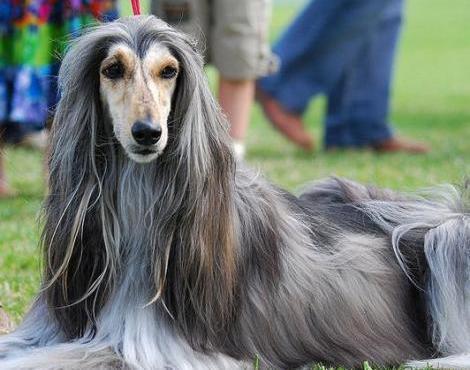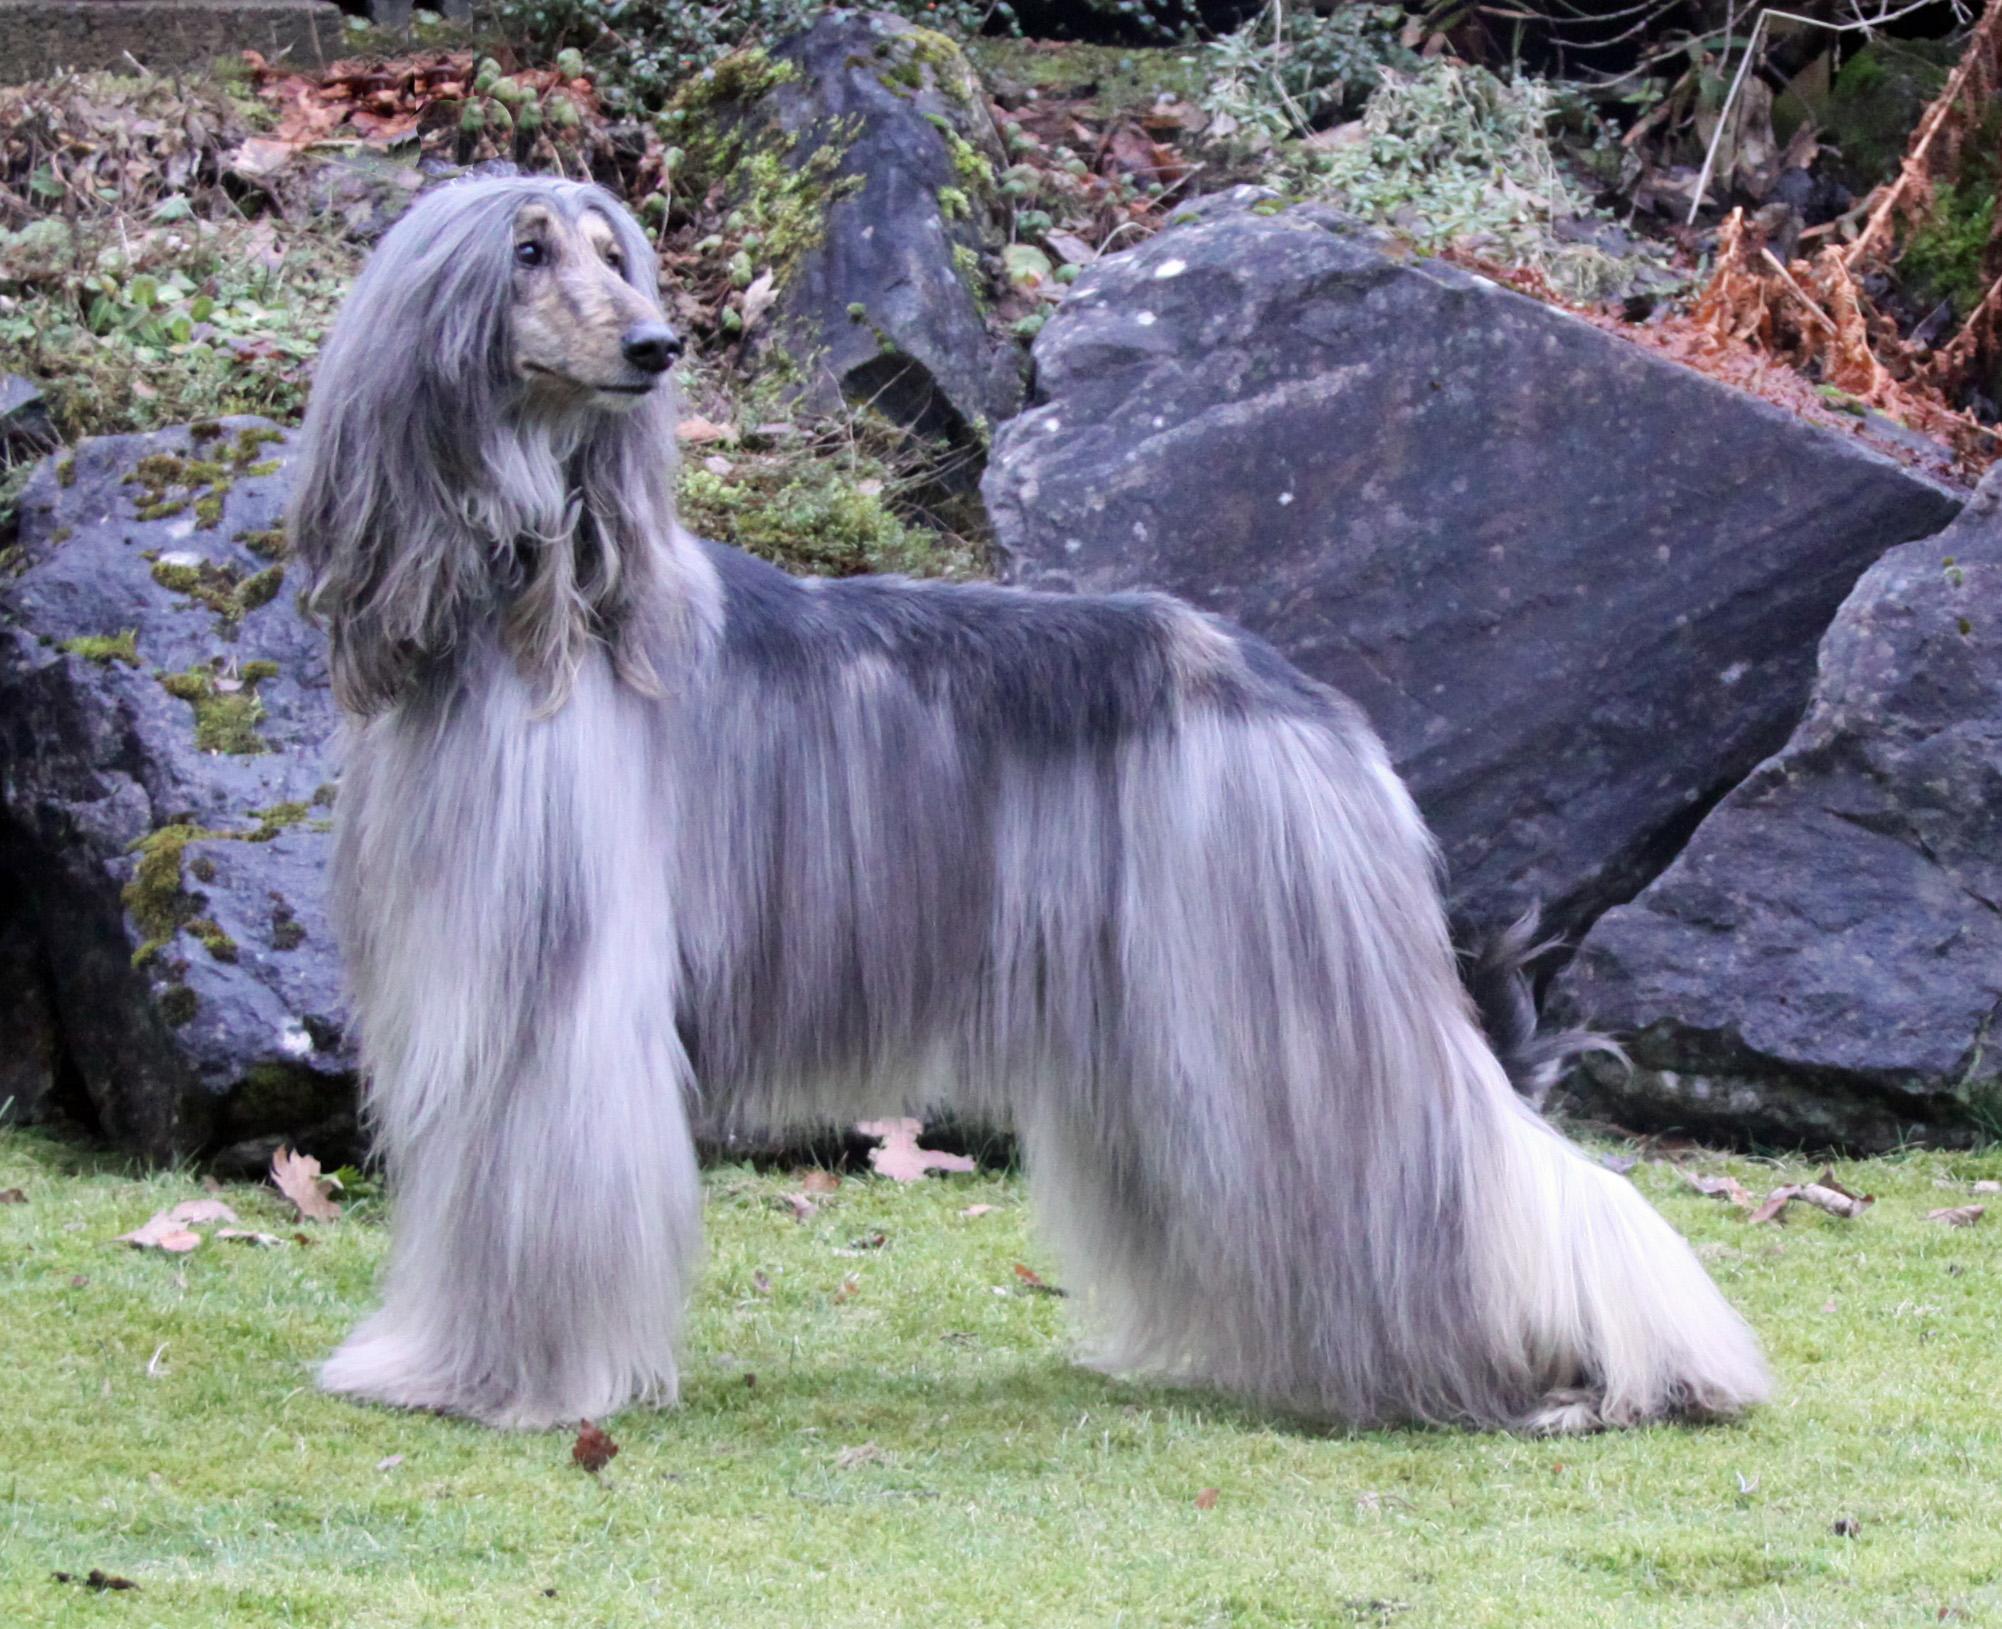The first image is the image on the left, the second image is the image on the right. Analyze the images presented: Is the assertion "All dogs shown have mostly gray fur." valid? Answer yes or no. Yes. 